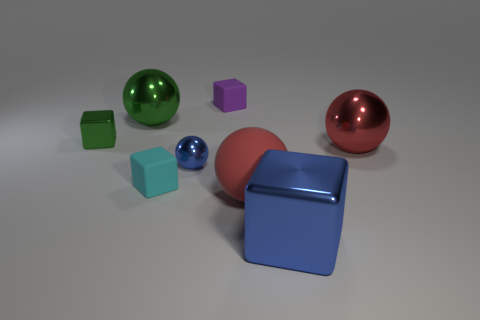There is a blue object that is the same shape as the red matte thing; what is its size?
Offer a terse response. Small. There is a small green metal object; are there any green things in front of it?
Offer a terse response. No. Are there an equal number of small cyan objects left of the large green metal thing and large cyan metal things?
Your answer should be compact. Yes. Is there a green thing that is in front of the block to the right of the tiny rubber cube behind the small cyan matte block?
Offer a very short reply. No. What is the material of the tiny blue thing?
Make the answer very short. Metal. What number of other objects are the same shape as the small purple thing?
Provide a short and direct response. 3. Is the shape of the big red metal object the same as the big red matte thing?
Ensure brevity in your answer.  Yes. What number of objects are either large spheres behind the tiny green shiny object or big objects behind the tiny green block?
Ensure brevity in your answer.  1. What number of things are tiny metallic objects or green shiny balls?
Your answer should be very brief. 3. There is a metallic block left of the tiny cyan thing; how many large objects are behind it?
Provide a short and direct response. 1. 